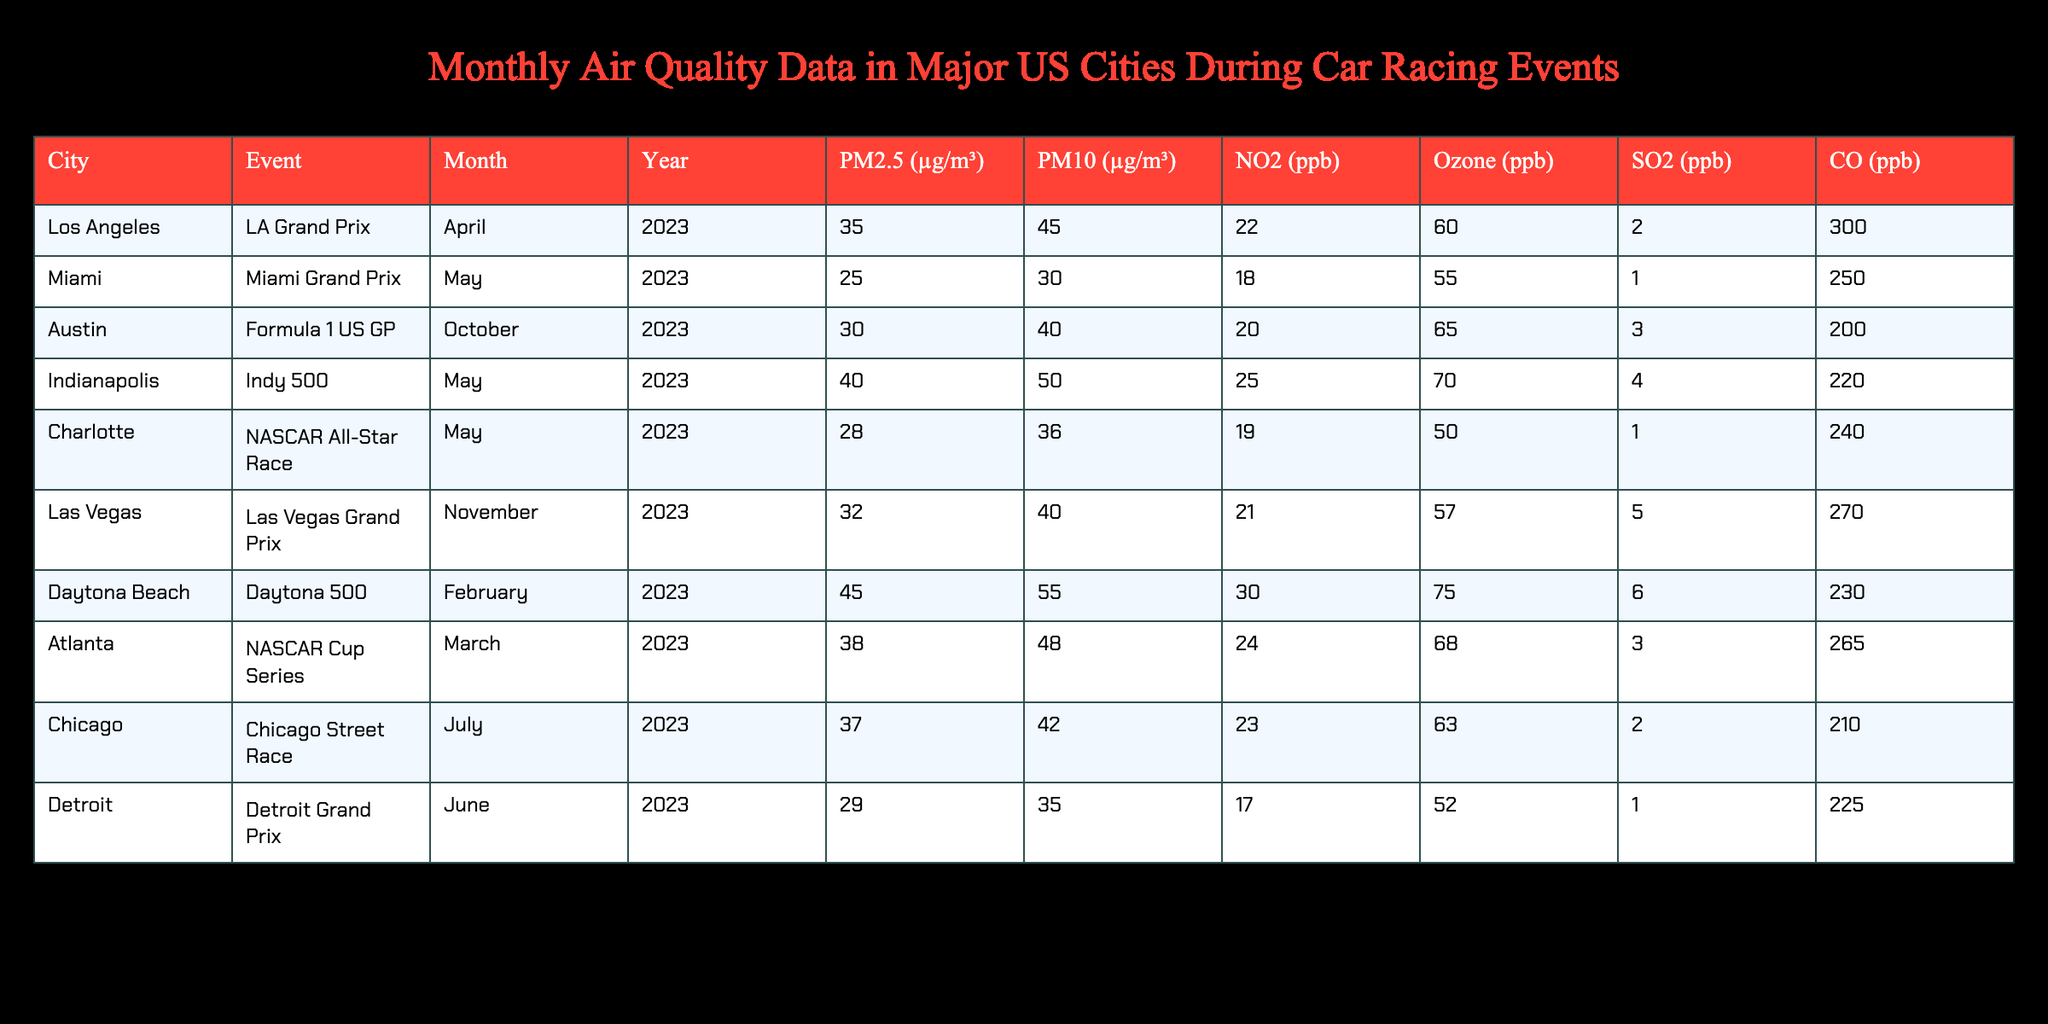What city had the highest PM2.5 level during a racing event? In the table, we can see that the PM2.5 levels for each city are listed under the PM2.5 column. Comparing all values, the highest PM2.5 level is 45 µg/m³ for Daytona Beach during the Daytona 500 in February 2023.
Answer: Daytona Beach What was the Ozone level in Chicago during the Chicago Street Race? Looking at the table, the Ozone level for Chicago during the Chicago Street Race in July 2023 is 63 ppb, as indicated in the Ozone column.
Answer: 63 ppb Which event in May had the lowest PM10 level? To find the event in May with the lowest PM10 level, we look at the rows for all events in May: Miami Grand Prix (30 µg/m³), Indy 500 (50 µg/m³), and NASCAR All-Star Race (36 µg/m³). The lowest PM10 level is 30 µg/m³ for the Miami Grand Prix.
Answer: Miami Grand Prix Is the NO2 level for Los Angeles during the LA Grand Prix above 20 ppb? According to the table, the NO2 level for Los Angeles during the LA Grand Prix is 22 ppb. Since 22 is indeed greater than 20, the statement is true.
Answer: Yes What is the average PM2.5 level for all events in May 2023? First, we find the PM2.5 levels for the events in May: Miami Grand Prix (25 µg/m³), Indy 500 (40 µg/m³), and NASCAR All-Star Race (28 µg/m³). We sum these values: 25 + 40 + 28 = 93 µg/m³. Then, we divide by the number of events (3): 93/3 = 31 µg/m³, resulting in an average of 31 µg/m³.
Answer: 31 µg/m³ Which city had the lowest CO level during an event, and what was the level? We need to examine the CO levels for each city in the table. The levels are: Los Angeles (300 ppb), Miami (250 ppb), Austin (200 ppb), Indianapolis (220 ppb), Charlotte (240 ppb), Las Vegas (270 ppb), Daytona Beach (230 ppb), Atlanta (265 ppb), Chicago (210 ppb), and Detroit (225 ppb). The lowest CO level is 200 ppb for Austin during the Formula 1 US GP.
Answer: Austin, 200 ppb 